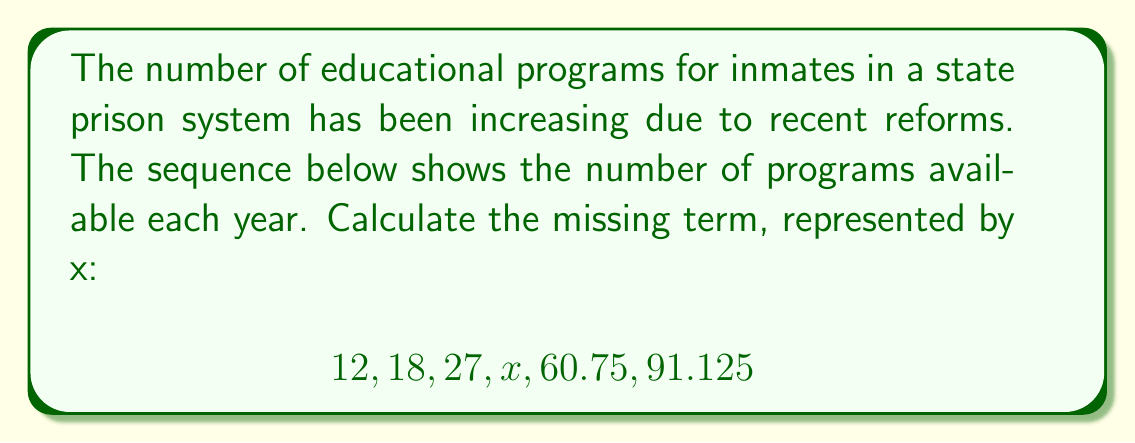Could you help me with this problem? To find the missing term, we need to identify the pattern in the sequence:

1) First, calculate the ratio between each consecutive term:
   $18 / 12 = 1.5$
   $27 / 18 = 1.5$
   $60.75 / x = 1.5$ (assuming the pattern continues)
   $91.125 / 60.75 = 1.5$

2) We can see that each term is 1.5 times the previous term.

3) To find x, we can use the relationship between x and 60.75:
   $60.75 = x * 1.5$

4) Solving for x:
   $x = 60.75 / 1.5 = 40.5$

5) Verify:
   $27 * 1.5 = 40.5$
   $40.5 * 1.5 = 60.75$

Therefore, the missing term in the sequence is 40.5.
Answer: 40.5 